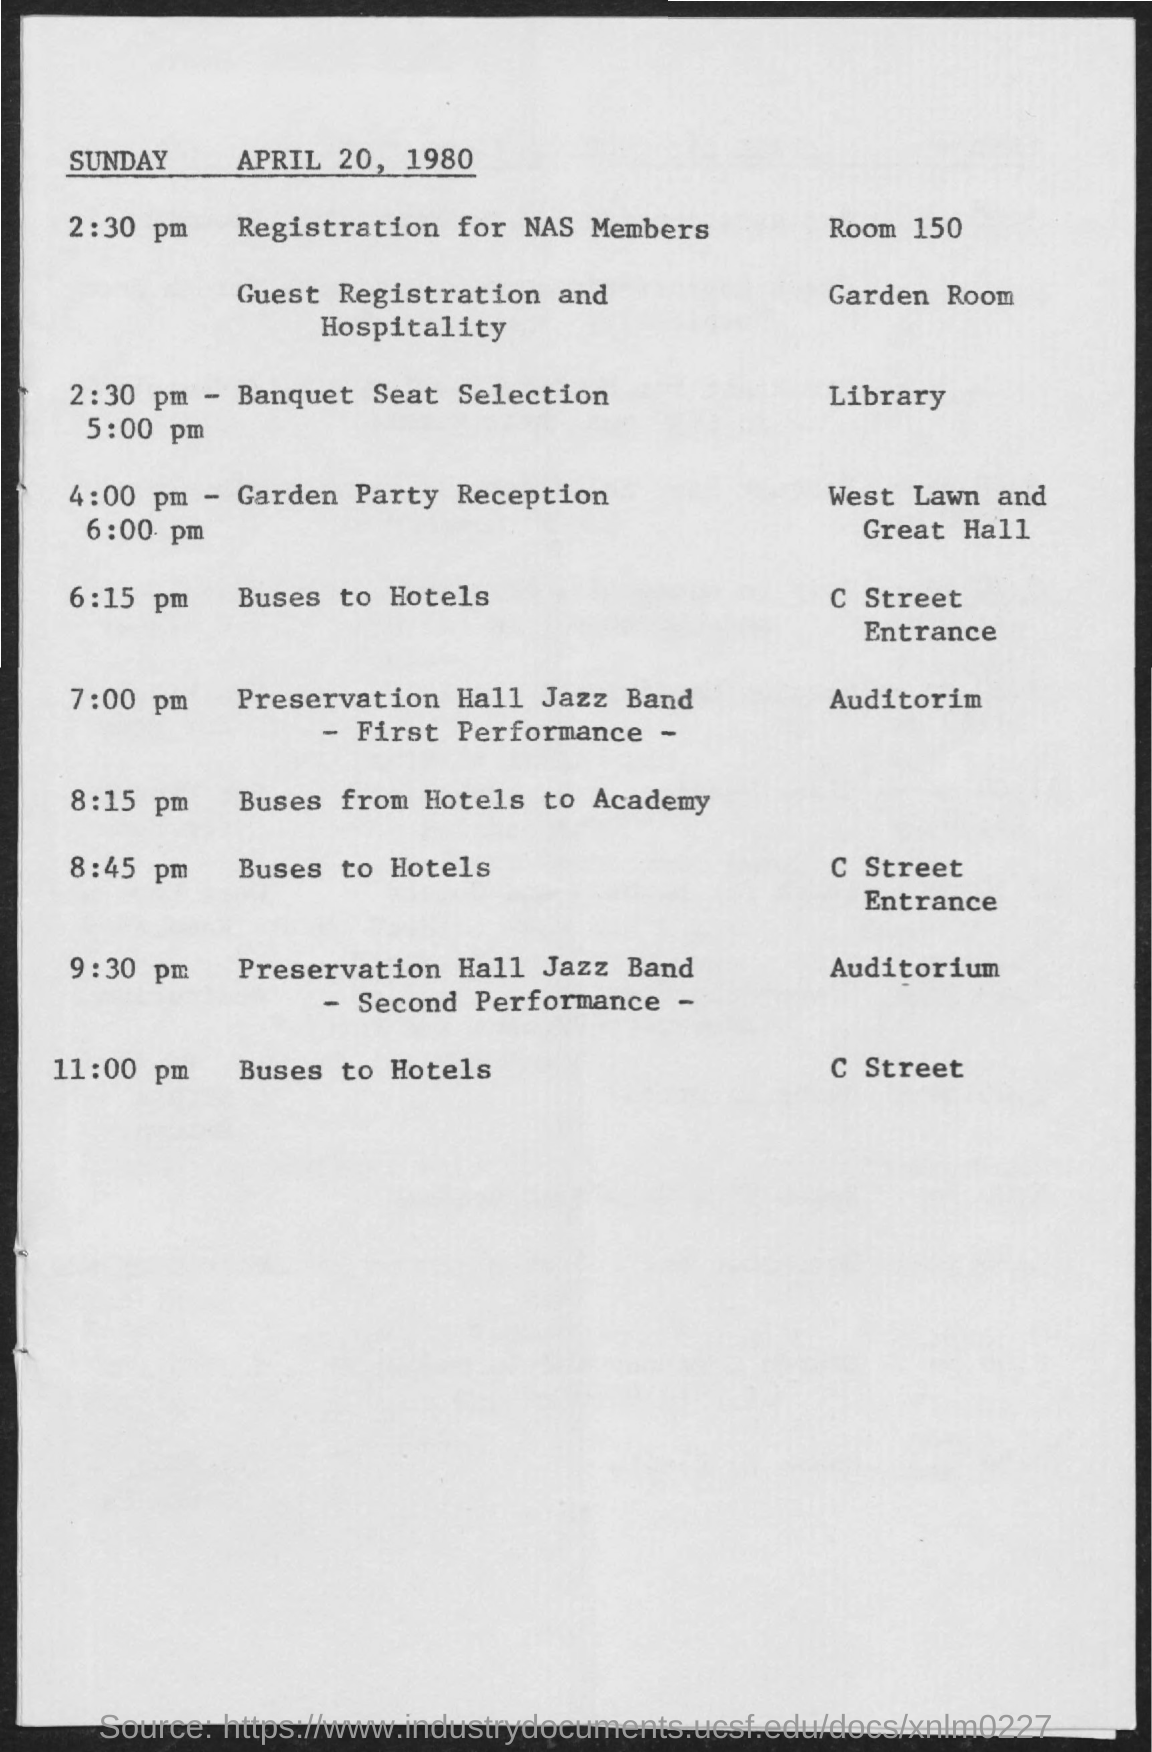Specify some key components in this picture. On Sunday, April 20, 1980, the Banquet Seat Selection was held at the Library. The Garden Party Reception organized on Sunday, April 20, 1980, was held from 4:00 PM to 6:00 PM. 